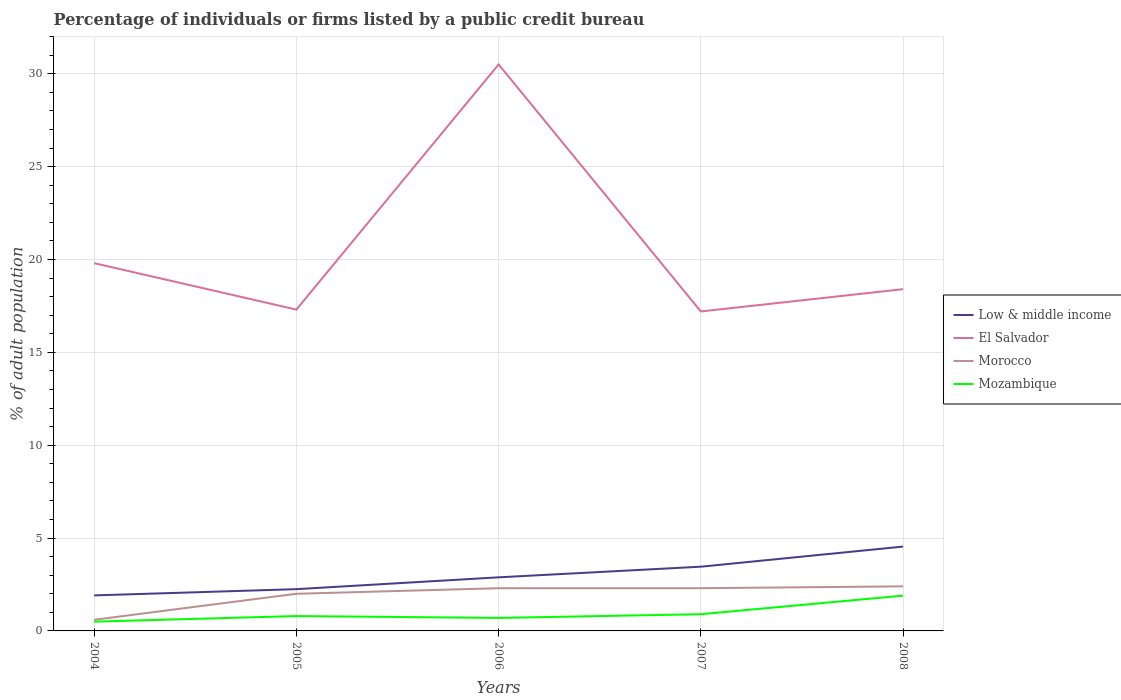How many different coloured lines are there?
Your response must be concise. 4. Does the line corresponding to El Salvador intersect with the line corresponding to Morocco?
Make the answer very short. No. Is the number of lines equal to the number of legend labels?
Your answer should be compact. Yes. In which year was the percentage of population listed by a public credit bureau in Morocco maximum?
Offer a terse response. 2004. What is the total percentage of population listed by a public credit bureau in Morocco in the graph?
Give a very brief answer. 0. What is the difference between the highest and the second highest percentage of population listed by a public credit bureau in Low & middle income?
Provide a short and direct response. 2.63. What is the difference between the highest and the lowest percentage of population listed by a public credit bureau in El Salvador?
Offer a terse response. 1. How many lines are there?
Your response must be concise. 4. How many years are there in the graph?
Give a very brief answer. 5. Does the graph contain grids?
Your response must be concise. Yes. What is the title of the graph?
Make the answer very short. Percentage of individuals or firms listed by a public credit bureau. What is the label or title of the X-axis?
Make the answer very short. Years. What is the label or title of the Y-axis?
Your answer should be very brief. % of adult population. What is the % of adult population in Low & middle income in 2004?
Give a very brief answer. 1.91. What is the % of adult population of El Salvador in 2004?
Keep it short and to the point. 19.8. What is the % of adult population of Morocco in 2004?
Make the answer very short. 0.6. What is the % of adult population in Low & middle income in 2005?
Give a very brief answer. 2.25. What is the % of adult population of El Salvador in 2005?
Your response must be concise. 17.3. What is the % of adult population in Morocco in 2005?
Your answer should be compact. 2. What is the % of adult population in Low & middle income in 2006?
Your response must be concise. 2.89. What is the % of adult population in El Salvador in 2006?
Your answer should be very brief. 30.5. What is the % of adult population of Morocco in 2006?
Give a very brief answer. 2.3. What is the % of adult population in Low & middle income in 2007?
Keep it short and to the point. 3.46. What is the % of adult population of El Salvador in 2007?
Ensure brevity in your answer.  17.2. What is the % of adult population of Morocco in 2007?
Offer a very short reply. 2.3. What is the % of adult population of Mozambique in 2007?
Your answer should be very brief. 0.9. What is the % of adult population in Low & middle income in 2008?
Your answer should be very brief. 4.54. What is the % of adult population of El Salvador in 2008?
Keep it short and to the point. 18.4. What is the % of adult population of Mozambique in 2008?
Offer a very short reply. 1.9. Across all years, what is the maximum % of adult population in Low & middle income?
Provide a succinct answer. 4.54. Across all years, what is the maximum % of adult population of El Salvador?
Ensure brevity in your answer.  30.5. Across all years, what is the maximum % of adult population of Morocco?
Give a very brief answer. 2.4. Across all years, what is the minimum % of adult population in Low & middle income?
Ensure brevity in your answer.  1.91. Across all years, what is the minimum % of adult population in Morocco?
Your answer should be compact. 0.6. What is the total % of adult population of Low & middle income in the graph?
Make the answer very short. 15.05. What is the total % of adult population of El Salvador in the graph?
Keep it short and to the point. 103.2. What is the difference between the % of adult population in Low & middle income in 2004 and that in 2005?
Make the answer very short. -0.34. What is the difference between the % of adult population of El Salvador in 2004 and that in 2005?
Ensure brevity in your answer.  2.5. What is the difference between the % of adult population of Morocco in 2004 and that in 2005?
Offer a terse response. -1.4. What is the difference between the % of adult population of Low & middle income in 2004 and that in 2006?
Provide a short and direct response. -0.97. What is the difference between the % of adult population in El Salvador in 2004 and that in 2006?
Your answer should be compact. -10.7. What is the difference between the % of adult population of Morocco in 2004 and that in 2006?
Ensure brevity in your answer.  -1.7. What is the difference between the % of adult population in Low & middle income in 2004 and that in 2007?
Ensure brevity in your answer.  -1.55. What is the difference between the % of adult population of Low & middle income in 2004 and that in 2008?
Keep it short and to the point. -2.63. What is the difference between the % of adult population in Morocco in 2004 and that in 2008?
Offer a terse response. -1.8. What is the difference between the % of adult population in Mozambique in 2004 and that in 2008?
Provide a short and direct response. -1.4. What is the difference between the % of adult population of Low & middle income in 2005 and that in 2006?
Keep it short and to the point. -0.64. What is the difference between the % of adult population in Low & middle income in 2005 and that in 2007?
Keep it short and to the point. -1.21. What is the difference between the % of adult population in El Salvador in 2005 and that in 2007?
Provide a succinct answer. 0.1. What is the difference between the % of adult population of Morocco in 2005 and that in 2007?
Keep it short and to the point. -0.3. What is the difference between the % of adult population in Mozambique in 2005 and that in 2007?
Ensure brevity in your answer.  -0.1. What is the difference between the % of adult population of Low & middle income in 2005 and that in 2008?
Give a very brief answer. -2.29. What is the difference between the % of adult population in Morocco in 2005 and that in 2008?
Ensure brevity in your answer.  -0.4. What is the difference between the % of adult population in Low & middle income in 2006 and that in 2007?
Make the answer very short. -0.57. What is the difference between the % of adult population of El Salvador in 2006 and that in 2007?
Offer a terse response. 13.3. What is the difference between the % of adult population of Morocco in 2006 and that in 2007?
Provide a succinct answer. 0. What is the difference between the % of adult population in Mozambique in 2006 and that in 2007?
Keep it short and to the point. -0.2. What is the difference between the % of adult population of Low & middle income in 2006 and that in 2008?
Your answer should be very brief. -1.66. What is the difference between the % of adult population of Morocco in 2006 and that in 2008?
Provide a succinct answer. -0.1. What is the difference between the % of adult population in Low & middle income in 2007 and that in 2008?
Make the answer very short. -1.08. What is the difference between the % of adult population of El Salvador in 2007 and that in 2008?
Ensure brevity in your answer.  -1.2. What is the difference between the % of adult population in Mozambique in 2007 and that in 2008?
Keep it short and to the point. -1. What is the difference between the % of adult population in Low & middle income in 2004 and the % of adult population in El Salvador in 2005?
Provide a short and direct response. -15.39. What is the difference between the % of adult population of Low & middle income in 2004 and the % of adult population of Morocco in 2005?
Your response must be concise. -0.09. What is the difference between the % of adult population in Low & middle income in 2004 and the % of adult population in Mozambique in 2005?
Give a very brief answer. 1.11. What is the difference between the % of adult population of El Salvador in 2004 and the % of adult population of Mozambique in 2005?
Give a very brief answer. 19. What is the difference between the % of adult population in Low & middle income in 2004 and the % of adult population in El Salvador in 2006?
Keep it short and to the point. -28.59. What is the difference between the % of adult population of Low & middle income in 2004 and the % of adult population of Morocco in 2006?
Your answer should be very brief. -0.39. What is the difference between the % of adult population in Low & middle income in 2004 and the % of adult population in Mozambique in 2006?
Offer a terse response. 1.21. What is the difference between the % of adult population in El Salvador in 2004 and the % of adult population in Morocco in 2006?
Offer a terse response. 17.5. What is the difference between the % of adult population in El Salvador in 2004 and the % of adult population in Mozambique in 2006?
Offer a very short reply. 19.1. What is the difference between the % of adult population in Morocco in 2004 and the % of adult population in Mozambique in 2006?
Your answer should be compact. -0.1. What is the difference between the % of adult population of Low & middle income in 2004 and the % of adult population of El Salvador in 2007?
Ensure brevity in your answer.  -15.29. What is the difference between the % of adult population in Low & middle income in 2004 and the % of adult population in Morocco in 2007?
Give a very brief answer. -0.39. What is the difference between the % of adult population in Low & middle income in 2004 and the % of adult population in Mozambique in 2007?
Offer a terse response. 1.01. What is the difference between the % of adult population of El Salvador in 2004 and the % of adult population of Morocco in 2007?
Offer a terse response. 17.5. What is the difference between the % of adult population of Morocco in 2004 and the % of adult population of Mozambique in 2007?
Your response must be concise. -0.3. What is the difference between the % of adult population in Low & middle income in 2004 and the % of adult population in El Salvador in 2008?
Your answer should be very brief. -16.49. What is the difference between the % of adult population of Low & middle income in 2004 and the % of adult population of Morocco in 2008?
Provide a short and direct response. -0.49. What is the difference between the % of adult population in Low & middle income in 2004 and the % of adult population in Mozambique in 2008?
Provide a short and direct response. 0.01. What is the difference between the % of adult population of El Salvador in 2004 and the % of adult population of Mozambique in 2008?
Keep it short and to the point. 17.9. What is the difference between the % of adult population of Low & middle income in 2005 and the % of adult population of El Salvador in 2006?
Your answer should be compact. -28.25. What is the difference between the % of adult population of Low & middle income in 2005 and the % of adult population of Morocco in 2006?
Ensure brevity in your answer.  -0.05. What is the difference between the % of adult population in Low & middle income in 2005 and the % of adult population in Mozambique in 2006?
Ensure brevity in your answer.  1.55. What is the difference between the % of adult population of El Salvador in 2005 and the % of adult population of Mozambique in 2006?
Your answer should be very brief. 16.6. What is the difference between the % of adult population in Morocco in 2005 and the % of adult population in Mozambique in 2006?
Provide a succinct answer. 1.3. What is the difference between the % of adult population of Low & middle income in 2005 and the % of adult population of El Salvador in 2007?
Provide a succinct answer. -14.95. What is the difference between the % of adult population of Low & middle income in 2005 and the % of adult population of Morocco in 2007?
Your response must be concise. -0.05. What is the difference between the % of adult population in Low & middle income in 2005 and the % of adult population in Mozambique in 2007?
Make the answer very short. 1.35. What is the difference between the % of adult population of Low & middle income in 2005 and the % of adult population of El Salvador in 2008?
Keep it short and to the point. -16.15. What is the difference between the % of adult population of Low & middle income in 2005 and the % of adult population of Morocco in 2008?
Provide a succinct answer. -0.15. What is the difference between the % of adult population in Low & middle income in 2005 and the % of adult population in Mozambique in 2008?
Provide a short and direct response. 0.35. What is the difference between the % of adult population of El Salvador in 2005 and the % of adult population of Morocco in 2008?
Offer a terse response. 14.9. What is the difference between the % of adult population of El Salvador in 2005 and the % of adult population of Mozambique in 2008?
Provide a short and direct response. 15.4. What is the difference between the % of adult population of Morocco in 2005 and the % of adult population of Mozambique in 2008?
Your response must be concise. 0.1. What is the difference between the % of adult population of Low & middle income in 2006 and the % of adult population of El Salvador in 2007?
Offer a very short reply. -14.31. What is the difference between the % of adult population in Low & middle income in 2006 and the % of adult population in Morocco in 2007?
Your answer should be compact. 0.59. What is the difference between the % of adult population of Low & middle income in 2006 and the % of adult population of Mozambique in 2007?
Your answer should be very brief. 1.99. What is the difference between the % of adult population in El Salvador in 2006 and the % of adult population in Morocco in 2007?
Provide a short and direct response. 28.2. What is the difference between the % of adult population of El Salvador in 2006 and the % of adult population of Mozambique in 2007?
Provide a succinct answer. 29.6. What is the difference between the % of adult population of Low & middle income in 2006 and the % of adult population of El Salvador in 2008?
Your answer should be very brief. -15.51. What is the difference between the % of adult population of Low & middle income in 2006 and the % of adult population of Morocco in 2008?
Your answer should be very brief. 0.49. What is the difference between the % of adult population of Low & middle income in 2006 and the % of adult population of Mozambique in 2008?
Provide a succinct answer. 0.99. What is the difference between the % of adult population in El Salvador in 2006 and the % of adult population in Morocco in 2008?
Your answer should be compact. 28.1. What is the difference between the % of adult population in El Salvador in 2006 and the % of adult population in Mozambique in 2008?
Give a very brief answer. 28.6. What is the difference between the % of adult population of Low & middle income in 2007 and the % of adult population of El Salvador in 2008?
Give a very brief answer. -14.94. What is the difference between the % of adult population in Low & middle income in 2007 and the % of adult population in Morocco in 2008?
Your answer should be very brief. 1.06. What is the difference between the % of adult population of Low & middle income in 2007 and the % of adult population of Mozambique in 2008?
Make the answer very short. 1.56. What is the difference between the % of adult population of El Salvador in 2007 and the % of adult population of Mozambique in 2008?
Your answer should be very brief. 15.3. What is the average % of adult population in Low & middle income per year?
Make the answer very short. 3.01. What is the average % of adult population in El Salvador per year?
Keep it short and to the point. 20.64. What is the average % of adult population in Morocco per year?
Your answer should be compact. 1.92. What is the average % of adult population of Mozambique per year?
Your response must be concise. 0.96. In the year 2004, what is the difference between the % of adult population in Low & middle income and % of adult population in El Salvador?
Offer a very short reply. -17.89. In the year 2004, what is the difference between the % of adult population of Low & middle income and % of adult population of Morocco?
Keep it short and to the point. 1.31. In the year 2004, what is the difference between the % of adult population of Low & middle income and % of adult population of Mozambique?
Ensure brevity in your answer.  1.41. In the year 2004, what is the difference between the % of adult population of El Salvador and % of adult population of Morocco?
Give a very brief answer. 19.2. In the year 2004, what is the difference between the % of adult population in El Salvador and % of adult population in Mozambique?
Make the answer very short. 19.3. In the year 2005, what is the difference between the % of adult population of Low & middle income and % of adult population of El Salvador?
Offer a very short reply. -15.05. In the year 2005, what is the difference between the % of adult population in Low & middle income and % of adult population in Morocco?
Keep it short and to the point. 0.25. In the year 2005, what is the difference between the % of adult population in Low & middle income and % of adult population in Mozambique?
Offer a very short reply. 1.45. In the year 2005, what is the difference between the % of adult population of El Salvador and % of adult population of Mozambique?
Your answer should be very brief. 16.5. In the year 2005, what is the difference between the % of adult population of Morocco and % of adult population of Mozambique?
Your answer should be very brief. 1.2. In the year 2006, what is the difference between the % of adult population in Low & middle income and % of adult population in El Salvador?
Ensure brevity in your answer.  -27.61. In the year 2006, what is the difference between the % of adult population of Low & middle income and % of adult population of Morocco?
Make the answer very short. 0.59. In the year 2006, what is the difference between the % of adult population in Low & middle income and % of adult population in Mozambique?
Offer a very short reply. 2.19. In the year 2006, what is the difference between the % of adult population of El Salvador and % of adult population of Morocco?
Offer a very short reply. 28.2. In the year 2006, what is the difference between the % of adult population in El Salvador and % of adult population in Mozambique?
Your response must be concise. 29.8. In the year 2006, what is the difference between the % of adult population of Morocco and % of adult population of Mozambique?
Provide a succinct answer. 1.6. In the year 2007, what is the difference between the % of adult population of Low & middle income and % of adult population of El Salvador?
Make the answer very short. -13.74. In the year 2007, what is the difference between the % of adult population of Low & middle income and % of adult population of Morocco?
Provide a succinct answer. 1.16. In the year 2007, what is the difference between the % of adult population in Low & middle income and % of adult population in Mozambique?
Keep it short and to the point. 2.56. In the year 2007, what is the difference between the % of adult population of El Salvador and % of adult population of Mozambique?
Your answer should be very brief. 16.3. In the year 2007, what is the difference between the % of adult population in Morocco and % of adult population in Mozambique?
Offer a very short reply. 1.4. In the year 2008, what is the difference between the % of adult population of Low & middle income and % of adult population of El Salvador?
Your response must be concise. -13.86. In the year 2008, what is the difference between the % of adult population in Low & middle income and % of adult population in Morocco?
Keep it short and to the point. 2.14. In the year 2008, what is the difference between the % of adult population of Low & middle income and % of adult population of Mozambique?
Provide a succinct answer. 2.64. In the year 2008, what is the difference between the % of adult population of El Salvador and % of adult population of Mozambique?
Give a very brief answer. 16.5. What is the ratio of the % of adult population of Low & middle income in 2004 to that in 2005?
Provide a succinct answer. 0.85. What is the ratio of the % of adult population in El Salvador in 2004 to that in 2005?
Your response must be concise. 1.14. What is the ratio of the % of adult population of Morocco in 2004 to that in 2005?
Keep it short and to the point. 0.3. What is the ratio of the % of adult population in Mozambique in 2004 to that in 2005?
Your response must be concise. 0.62. What is the ratio of the % of adult population in Low & middle income in 2004 to that in 2006?
Keep it short and to the point. 0.66. What is the ratio of the % of adult population of El Salvador in 2004 to that in 2006?
Offer a very short reply. 0.65. What is the ratio of the % of adult population of Morocco in 2004 to that in 2006?
Your response must be concise. 0.26. What is the ratio of the % of adult population in Low & middle income in 2004 to that in 2007?
Provide a short and direct response. 0.55. What is the ratio of the % of adult population of El Salvador in 2004 to that in 2007?
Keep it short and to the point. 1.15. What is the ratio of the % of adult population of Morocco in 2004 to that in 2007?
Your response must be concise. 0.26. What is the ratio of the % of adult population of Mozambique in 2004 to that in 2007?
Offer a very short reply. 0.56. What is the ratio of the % of adult population in Low & middle income in 2004 to that in 2008?
Provide a succinct answer. 0.42. What is the ratio of the % of adult population of El Salvador in 2004 to that in 2008?
Your answer should be very brief. 1.08. What is the ratio of the % of adult population of Morocco in 2004 to that in 2008?
Give a very brief answer. 0.25. What is the ratio of the % of adult population in Mozambique in 2004 to that in 2008?
Give a very brief answer. 0.26. What is the ratio of the % of adult population of Low & middle income in 2005 to that in 2006?
Make the answer very short. 0.78. What is the ratio of the % of adult population in El Salvador in 2005 to that in 2006?
Keep it short and to the point. 0.57. What is the ratio of the % of adult population of Morocco in 2005 to that in 2006?
Your answer should be very brief. 0.87. What is the ratio of the % of adult population of Mozambique in 2005 to that in 2006?
Provide a short and direct response. 1.14. What is the ratio of the % of adult population in Low & middle income in 2005 to that in 2007?
Provide a short and direct response. 0.65. What is the ratio of the % of adult population of Morocco in 2005 to that in 2007?
Offer a very short reply. 0.87. What is the ratio of the % of adult population of Low & middle income in 2005 to that in 2008?
Ensure brevity in your answer.  0.5. What is the ratio of the % of adult population in El Salvador in 2005 to that in 2008?
Provide a succinct answer. 0.94. What is the ratio of the % of adult population of Morocco in 2005 to that in 2008?
Offer a very short reply. 0.83. What is the ratio of the % of adult population in Mozambique in 2005 to that in 2008?
Offer a very short reply. 0.42. What is the ratio of the % of adult population in Low & middle income in 2006 to that in 2007?
Your answer should be very brief. 0.83. What is the ratio of the % of adult population in El Salvador in 2006 to that in 2007?
Provide a succinct answer. 1.77. What is the ratio of the % of adult population of Low & middle income in 2006 to that in 2008?
Give a very brief answer. 0.64. What is the ratio of the % of adult population of El Salvador in 2006 to that in 2008?
Make the answer very short. 1.66. What is the ratio of the % of adult population of Mozambique in 2006 to that in 2008?
Your answer should be compact. 0.37. What is the ratio of the % of adult population of Low & middle income in 2007 to that in 2008?
Give a very brief answer. 0.76. What is the ratio of the % of adult population of El Salvador in 2007 to that in 2008?
Offer a very short reply. 0.93. What is the ratio of the % of adult population of Mozambique in 2007 to that in 2008?
Provide a short and direct response. 0.47. What is the difference between the highest and the second highest % of adult population in Low & middle income?
Give a very brief answer. 1.08. What is the difference between the highest and the second highest % of adult population of El Salvador?
Make the answer very short. 10.7. What is the difference between the highest and the lowest % of adult population of Low & middle income?
Give a very brief answer. 2.63. What is the difference between the highest and the lowest % of adult population in Morocco?
Make the answer very short. 1.8. 